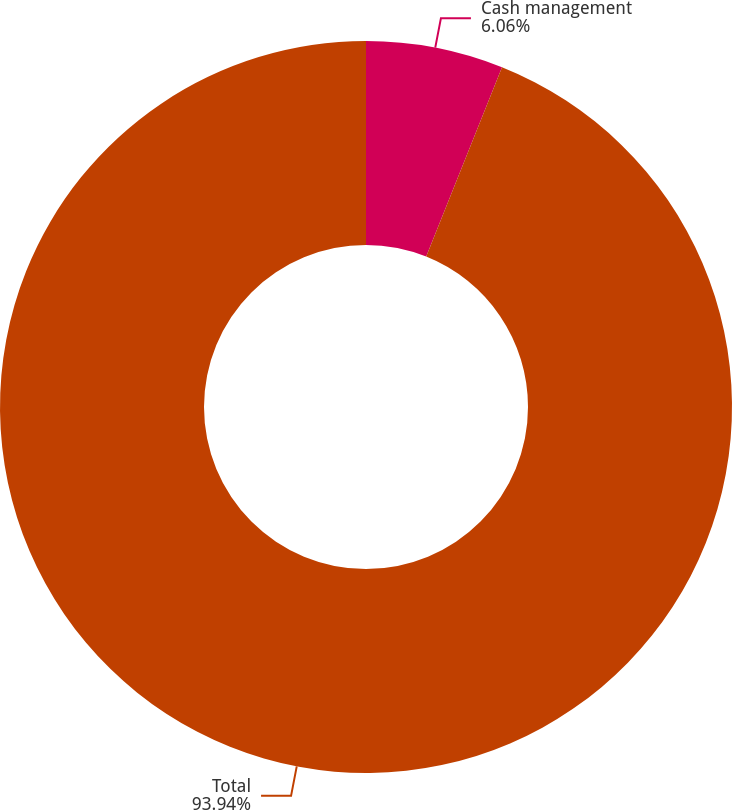Convert chart. <chart><loc_0><loc_0><loc_500><loc_500><pie_chart><fcel>Cash management<fcel>Total<nl><fcel>6.06%<fcel>93.94%<nl></chart> 